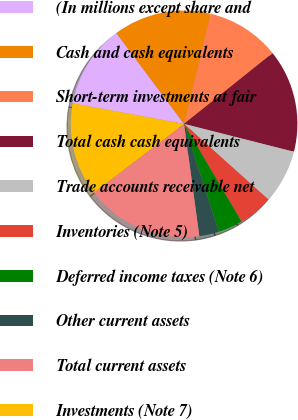Convert chart to OTSL. <chart><loc_0><loc_0><loc_500><loc_500><pie_chart><fcel>(In millions except share and<fcel>Cash and cash equivalents<fcel>Short-term investments at fair<fcel>Total cash cash equivalents<fcel>Trade accounts receivable net<fcel>Inventories (Note 5)<fcel>Deferred income taxes (Note 6)<fcel>Other current assets<fcel>Total current assets<fcel>Investments (Note 7)<nl><fcel>11.89%<fcel>13.98%<fcel>10.49%<fcel>14.68%<fcel>7.69%<fcel>4.9%<fcel>3.5%<fcel>2.81%<fcel>16.78%<fcel>13.28%<nl></chart> 